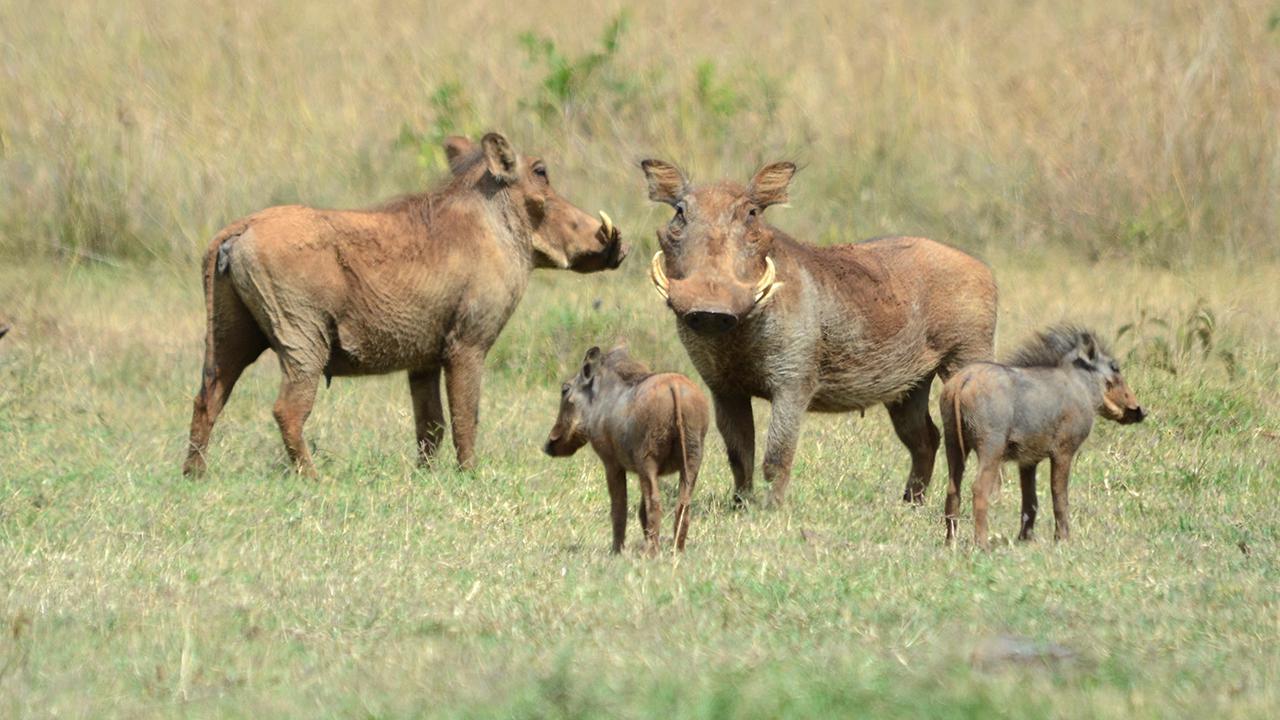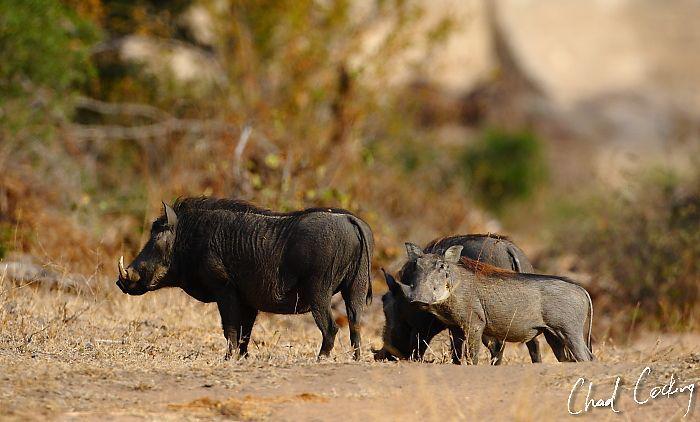The first image is the image on the left, the second image is the image on the right. For the images shown, is this caption "One of the images contains exactly two baby boars." true? Answer yes or no. Yes. The first image is the image on the left, the second image is the image on the right. Given the left and right images, does the statement "Right image contains one forward facing adult boar and multiple baby boars." hold true? Answer yes or no. No. 